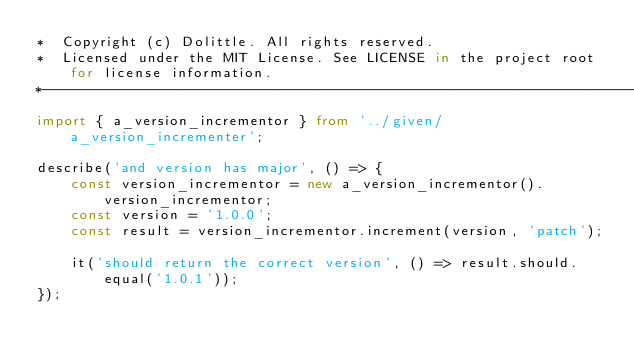<code> <loc_0><loc_0><loc_500><loc_500><_TypeScript_>*  Copyright (c) Dolittle. All rights reserved.
*  Licensed under the MIT License. See LICENSE in the project root for license information.
*--------------------------------------------------------------------------------------------*/
import { a_version_incrementor } from '../given/a_version_incrementer';

describe('and version has major', () => {
    const version_incrementor = new a_version_incrementor().version_incrementor;
    const version = '1.0.0';
    const result = version_incrementor.increment(version, 'patch');

    it('should return the correct version', () => result.should.equal('1.0.1'));
});
</code> 